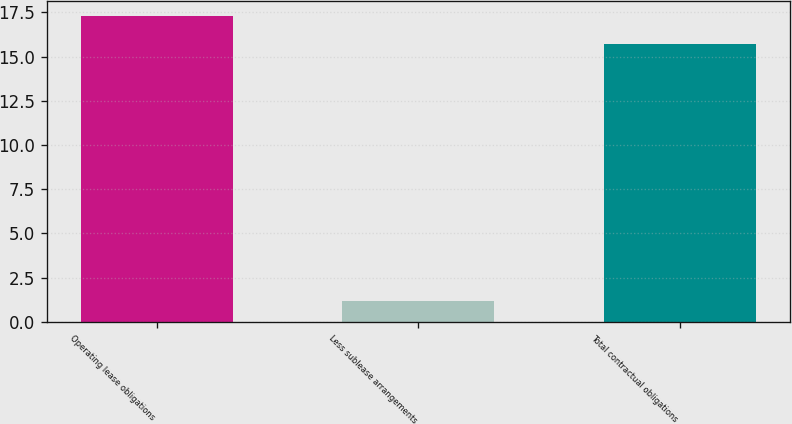<chart> <loc_0><loc_0><loc_500><loc_500><bar_chart><fcel>Operating lease obligations<fcel>Less sublease arrangements<fcel>Total contractual obligations<nl><fcel>17.27<fcel>1.2<fcel>15.7<nl></chart> 